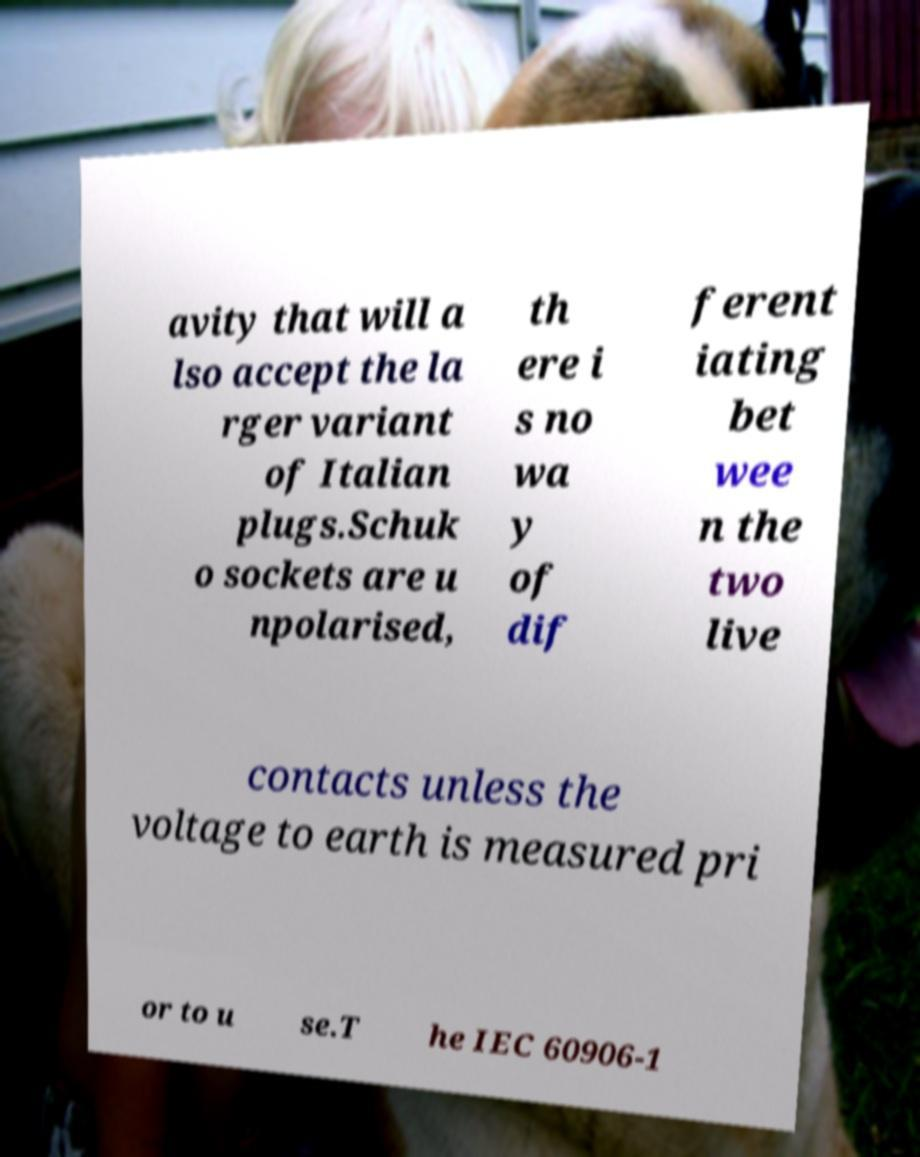Can you read and provide the text displayed in the image?This photo seems to have some interesting text. Can you extract and type it out for me? avity that will a lso accept the la rger variant of Italian plugs.Schuk o sockets are u npolarised, th ere i s no wa y of dif ferent iating bet wee n the two live contacts unless the voltage to earth is measured pri or to u se.T he IEC 60906-1 